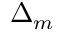Convert formula to latex. <formula><loc_0><loc_0><loc_500><loc_500>\Delta _ { m }</formula> 